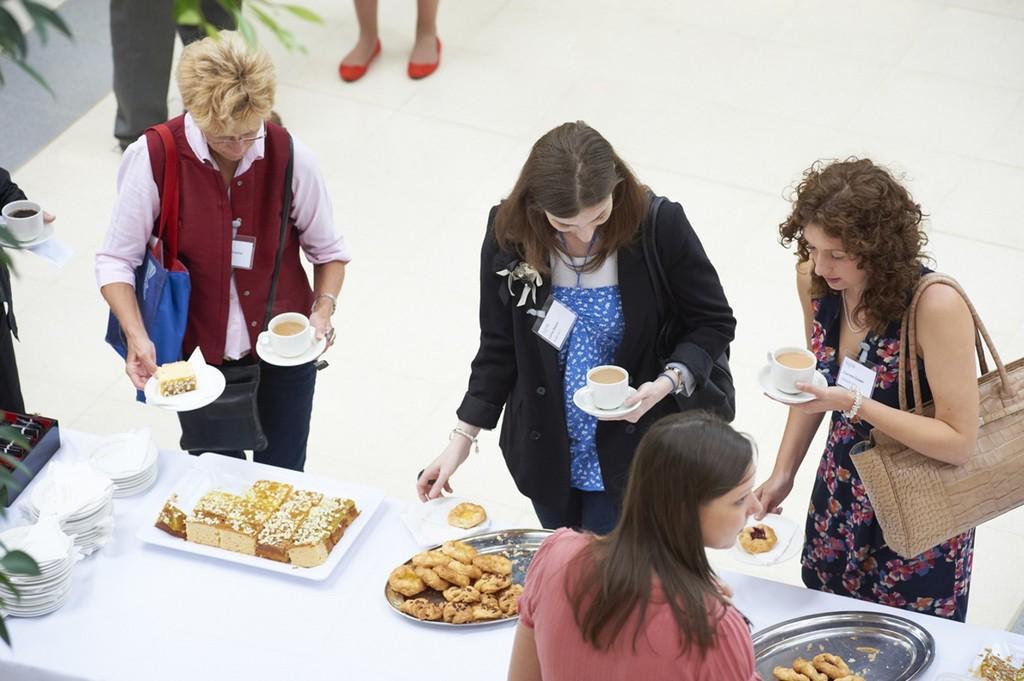Who or what is present in the image? There are people in the image. What object can be seen in the image that is commonly used for eating or serving food? There is a table in the image. What items are placed on the table? There are trays and plates on the table. What type of items can be found on the table that people might eat? There are food items on the table. What amusement park ride is depicted in the image? There is no amusement park ride present in the image; it features people, a table, trays, plates, and food items. 